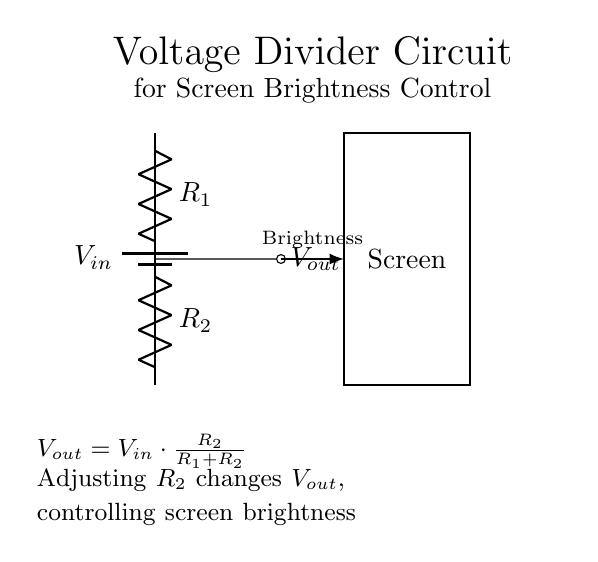What is the input voltage in this circuit? The input voltage is indicated by the label V_in on the battery. It represents the voltage supplied to the circuit before any other components affect it.
Answer: V_in What are the two resistors in the circuit? The circuit has two resistors labeled as R_1 and R_2. They are connected in series and form the voltage divider that adjusts the output voltage for brightness control.
Answer: R_1 and R_2 What does V_out represent in this circuit? V_out represents the output voltage that is delivered to the screen after the voltage divider effect of R_1 and R_2 has been applied to the input voltage.
Answer: V_out How does changing R_2 affect the screen brightness? Changing R_2 alters the ratio of R_2 to the total resistance (R_1 + R_2), which in turn changes V_out according to the voltage divider formula, thus affecting screen brightness.
Answer: Adjusts V_out What is the formula for calculating V_out in this circuit? The formula for V_out is given as V_out = V_in * (R_2 / (R_1 + R_2)), which quantitatively describes how the output voltage relates to the resistors and input voltage.
Answer: V_out = V_in * (R_2 / (R_1 + R_2)) What is the role of the arrow labeled "Brightness" in the diagram? The arrow labeled "Brightness" visually indicates that the adjustment of R_2 will control or vary the brightness of the screen by affecting the output voltage V_out.
Answer: Brightness adjustment 